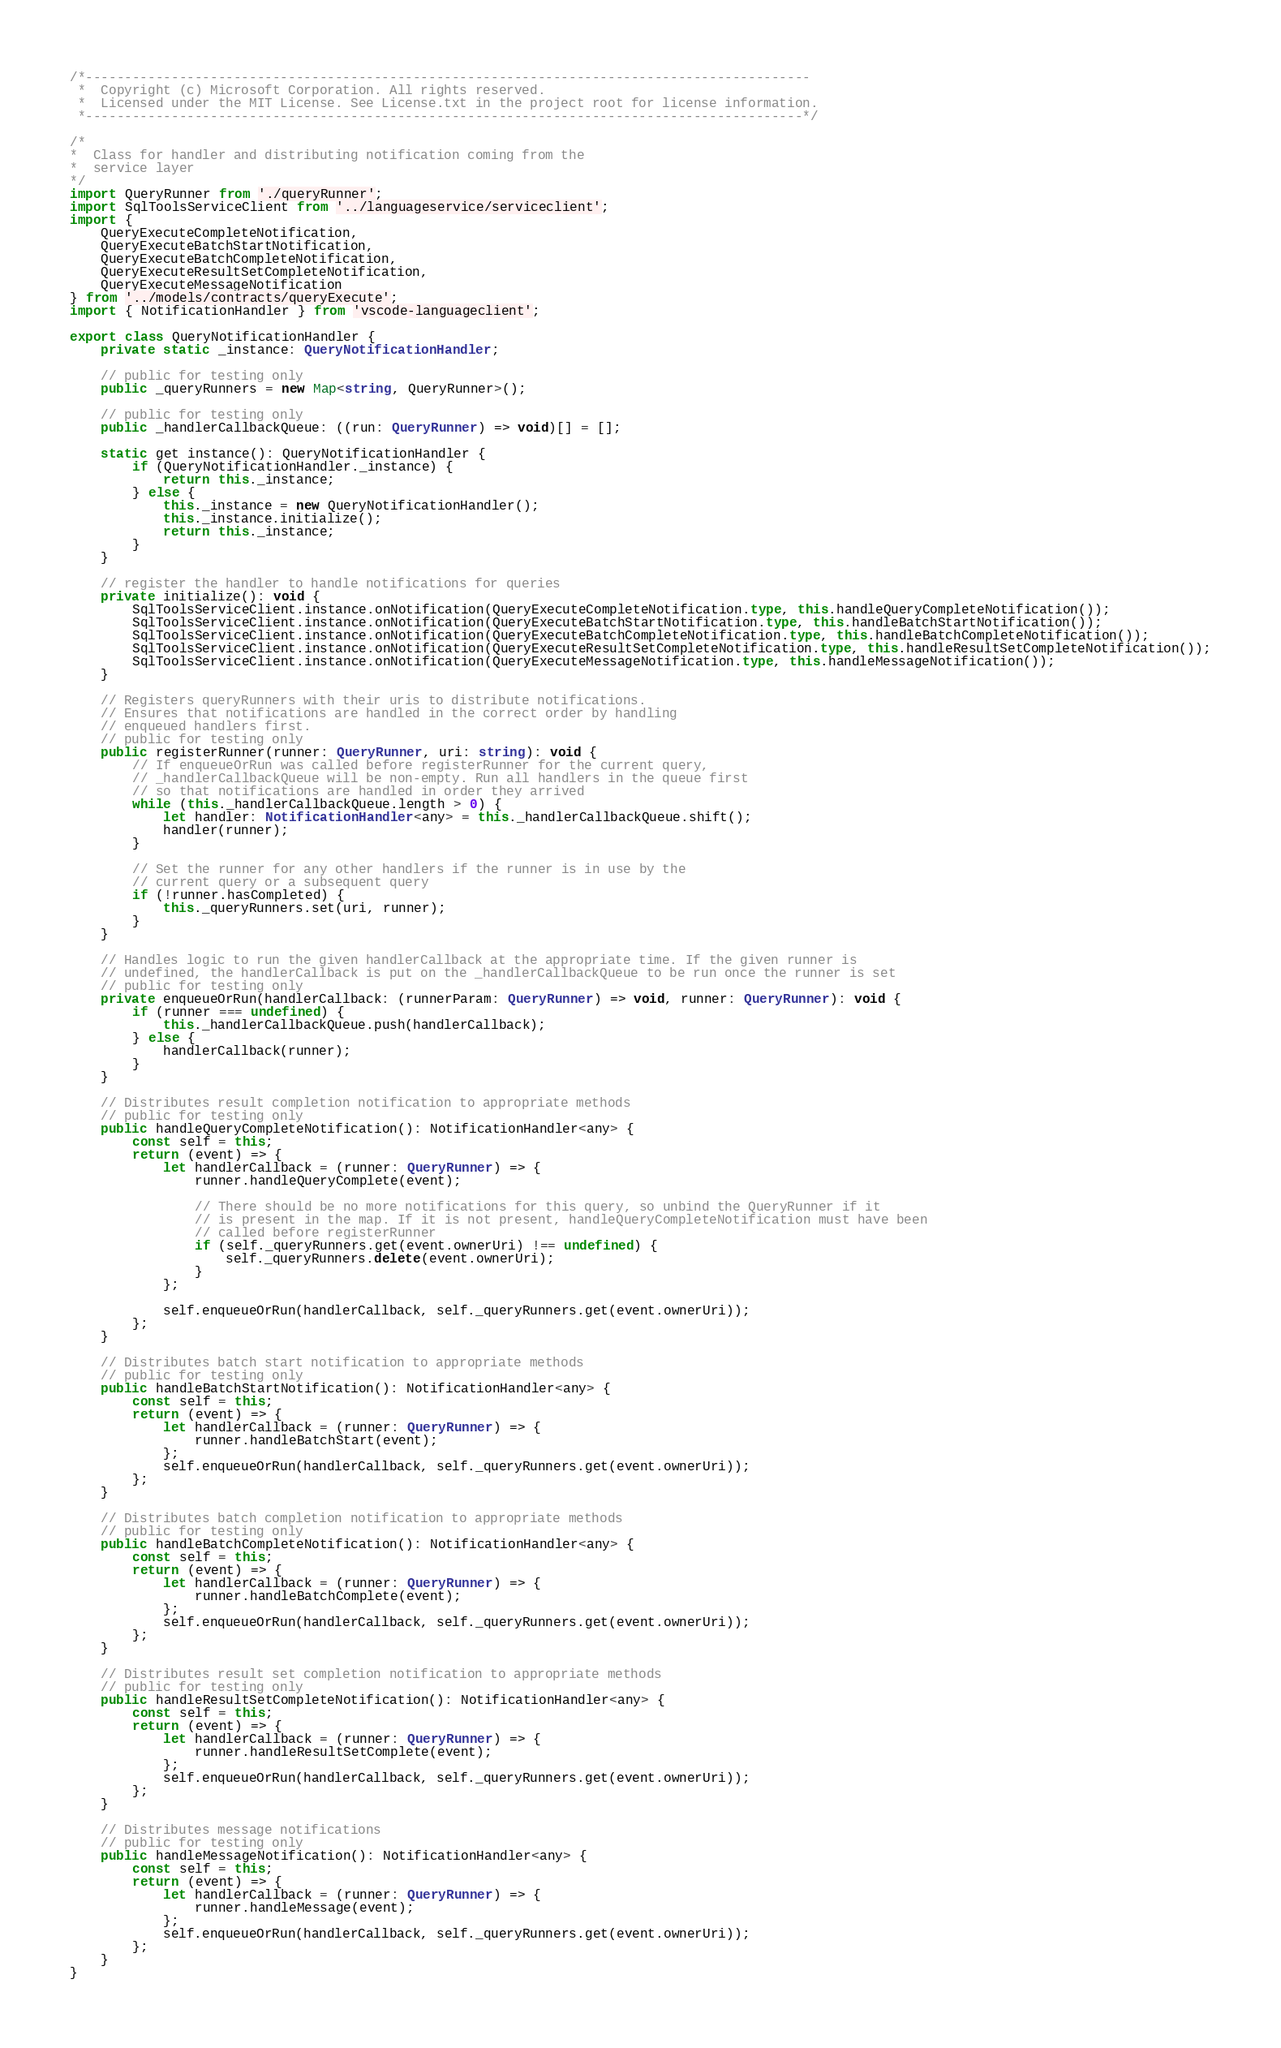<code> <loc_0><loc_0><loc_500><loc_500><_TypeScript_>/*---------------------------------------------------------------------------------------------
 *  Copyright (c) Microsoft Corporation. All rights reserved.
 *  Licensed under the MIT License. See License.txt in the project root for license information.
 *--------------------------------------------------------------------------------------------*/

/*
*  Class for handler and distributing notification coming from the
*  service layer
*/
import QueryRunner from './queryRunner';
import SqlToolsServiceClient from '../languageservice/serviceclient';
import {
    QueryExecuteCompleteNotification,
    QueryExecuteBatchStartNotification,
    QueryExecuteBatchCompleteNotification,
    QueryExecuteResultSetCompleteNotification,
    QueryExecuteMessageNotification
} from '../models/contracts/queryExecute';
import { NotificationHandler } from 'vscode-languageclient';

export class QueryNotificationHandler {
    private static _instance: QueryNotificationHandler;

    // public for testing only
    public _queryRunners = new Map<string, QueryRunner>();

    // public for testing only
    public _handlerCallbackQueue: ((run: QueryRunner) => void)[] = [];

    static get instance(): QueryNotificationHandler {
        if (QueryNotificationHandler._instance) {
            return this._instance;
        } else {
            this._instance = new QueryNotificationHandler();
            this._instance.initialize();
            return this._instance;
        }
    }

    // register the handler to handle notifications for queries
    private initialize(): void {
        SqlToolsServiceClient.instance.onNotification(QueryExecuteCompleteNotification.type, this.handleQueryCompleteNotification());
        SqlToolsServiceClient.instance.onNotification(QueryExecuteBatchStartNotification.type, this.handleBatchStartNotification());
        SqlToolsServiceClient.instance.onNotification(QueryExecuteBatchCompleteNotification.type, this.handleBatchCompleteNotification());
        SqlToolsServiceClient.instance.onNotification(QueryExecuteResultSetCompleteNotification.type, this.handleResultSetCompleteNotification());
        SqlToolsServiceClient.instance.onNotification(QueryExecuteMessageNotification.type, this.handleMessageNotification());
    }

    // Registers queryRunners with their uris to distribute notifications.
    // Ensures that notifications are handled in the correct order by handling
    // enqueued handlers first.
    // public for testing only
    public registerRunner(runner: QueryRunner, uri: string): void {
        // If enqueueOrRun was called before registerRunner for the current query,
        // _handlerCallbackQueue will be non-empty. Run all handlers in the queue first
        // so that notifications are handled in order they arrived
        while (this._handlerCallbackQueue.length > 0) {
            let handler: NotificationHandler<any> = this._handlerCallbackQueue.shift();
            handler(runner);
        }

        // Set the runner for any other handlers if the runner is in use by the
        // current query or a subsequent query
        if (!runner.hasCompleted) {
            this._queryRunners.set(uri, runner);
        }
    }

    // Handles logic to run the given handlerCallback at the appropriate time. If the given runner is
    // undefined, the handlerCallback is put on the _handlerCallbackQueue to be run once the runner is set
    // public for testing only
    private enqueueOrRun(handlerCallback: (runnerParam: QueryRunner) => void, runner: QueryRunner): void {
        if (runner === undefined) {
            this._handlerCallbackQueue.push(handlerCallback);
        } else {
            handlerCallback(runner);
        }
    }

    // Distributes result completion notification to appropriate methods
    // public for testing only
    public handleQueryCompleteNotification(): NotificationHandler<any> {
        const self = this;
        return (event) => {
            let handlerCallback = (runner: QueryRunner) => {
                runner.handleQueryComplete(event);

                // There should be no more notifications for this query, so unbind the QueryRunner if it
                // is present in the map. If it is not present, handleQueryCompleteNotification must have been
                // called before registerRunner
                if (self._queryRunners.get(event.ownerUri) !== undefined) {
                    self._queryRunners.delete(event.ownerUri);
                }
            };

            self.enqueueOrRun(handlerCallback, self._queryRunners.get(event.ownerUri));
        };
    }

    // Distributes batch start notification to appropriate methods
    // public for testing only
    public handleBatchStartNotification(): NotificationHandler<any> {
        const self = this;
        return (event) => {
            let handlerCallback = (runner: QueryRunner) => {
                runner.handleBatchStart(event);
            };
            self.enqueueOrRun(handlerCallback, self._queryRunners.get(event.ownerUri));
        };
    }

    // Distributes batch completion notification to appropriate methods
    // public for testing only
    public handleBatchCompleteNotification(): NotificationHandler<any> {
        const self = this;
        return (event) => {
            let handlerCallback = (runner: QueryRunner) => {
                runner.handleBatchComplete(event);
            };
            self.enqueueOrRun(handlerCallback, self._queryRunners.get(event.ownerUri));
        };
    }

    // Distributes result set completion notification to appropriate methods
    // public for testing only
    public handleResultSetCompleteNotification(): NotificationHandler<any> {
        const self = this;
        return (event) => {
            let handlerCallback = (runner: QueryRunner) => {
                runner.handleResultSetComplete(event);
            };
            self.enqueueOrRun(handlerCallback, self._queryRunners.get(event.ownerUri));
        };
    }

    // Distributes message notifications
    // public for testing only
    public handleMessageNotification(): NotificationHandler<any> {
        const self = this;
        return (event) => {
            let handlerCallback = (runner: QueryRunner) => {
                runner.handleMessage(event);
            };
            self.enqueueOrRun(handlerCallback, self._queryRunners.get(event.ownerUri));
        };
    }
}
</code> 